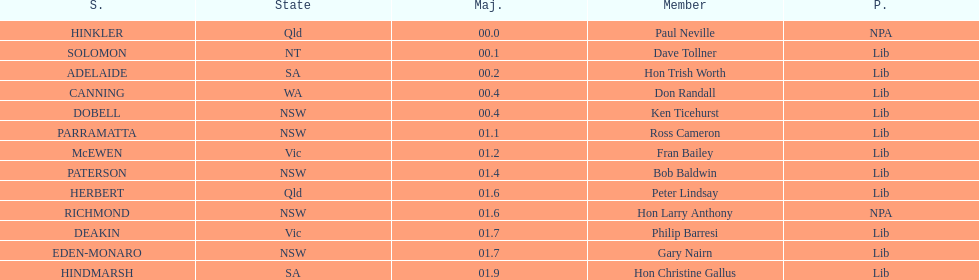Which member follows after hon trish worth? Don Randall. 